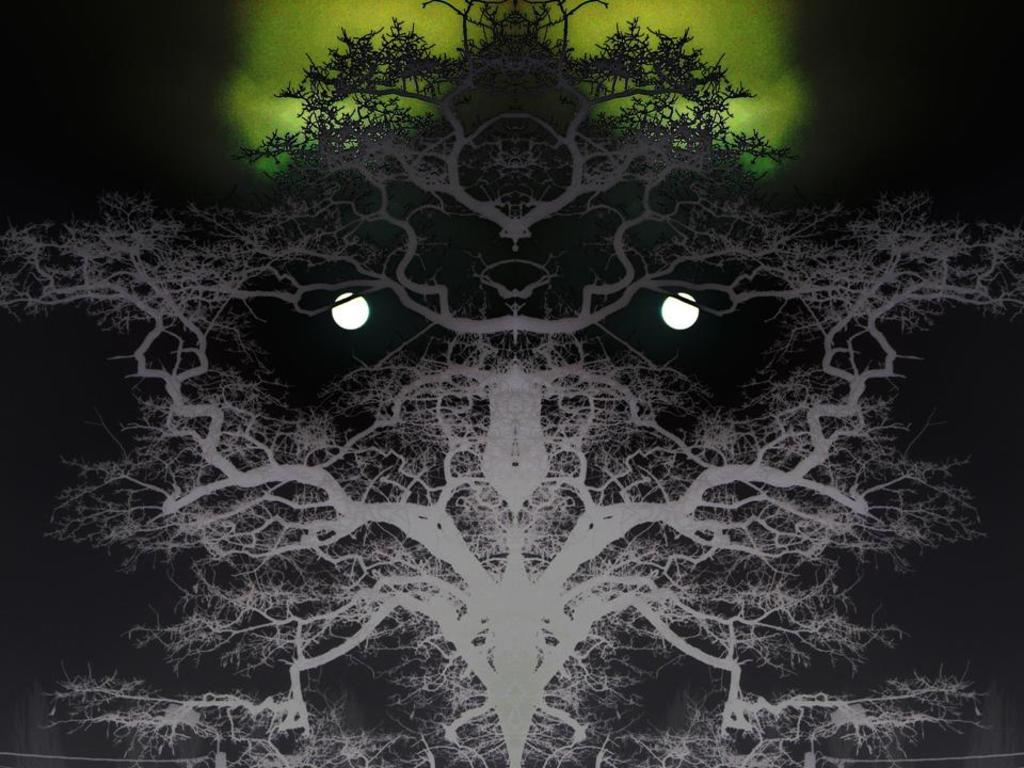In one or two sentences, can you explain what this image depicts? In this picture we can see the mirror image. On that we can see trees, moon and green object. In the top right corner we can see the darkness. 